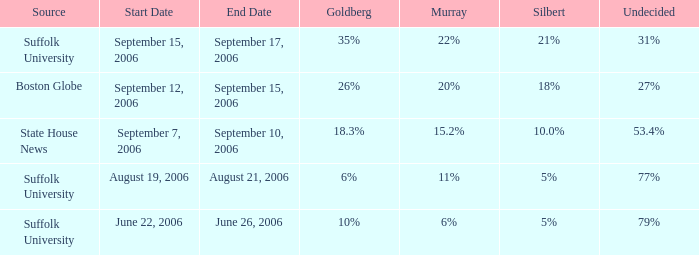In the suffolk university poll, when did murray achieve an 11% result? August 19–21, 2006. 